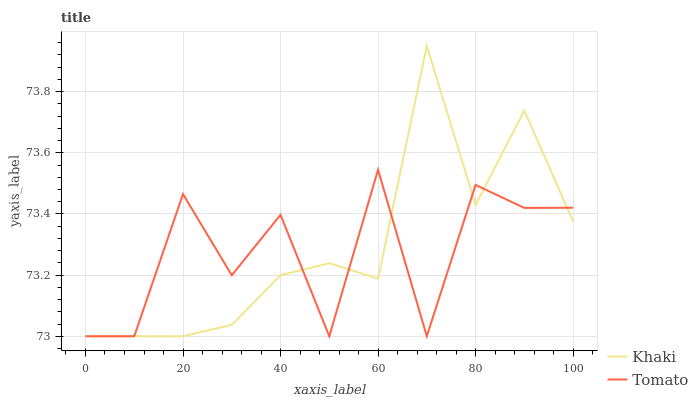Does Tomato have the minimum area under the curve?
Answer yes or no. Yes. Does Khaki have the maximum area under the curve?
Answer yes or no. Yes. Does Khaki have the minimum area under the curve?
Answer yes or no. No. Is Khaki the smoothest?
Answer yes or no. Yes. Is Tomato the roughest?
Answer yes or no. Yes. Is Khaki the roughest?
Answer yes or no. No. Does Tomato have the lowest value?
Answer yes or no. Yes. Does Khaki have the highest value?
Answer yes or no. Yes. Does Khaki intersect Tomato?
Answer yes or no. Yes. Is Khaki less than Tomato?
Answer yes or no. No. Is Khaki greater than Tomato?
Answer yes or no. No. 